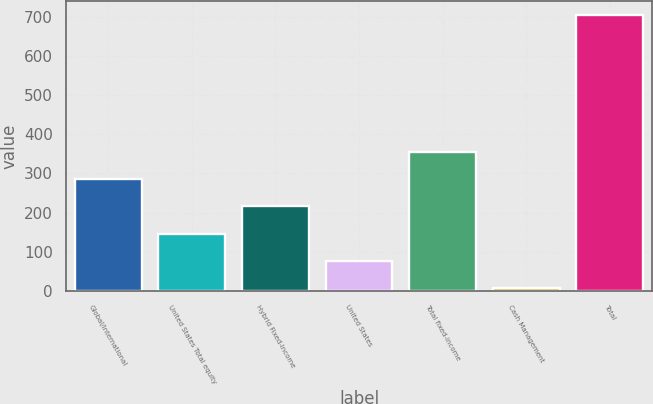Convert chart. <chart><loc_0><loc_0><loc_500><loc_500><bar_chart><fcel>Global/international<fcel>United States Total equity<fcel>Hybrid Fixed-Income<fcel>United States<fcel>Total fixed-income<fcel>Cash Management<fcel>Total<nl><fcel>286.06<fcel>146.18<fcel>216.12<fcel>76.24<fcel>356<fcel>6.3<fcel>705.7<nl></chart> 